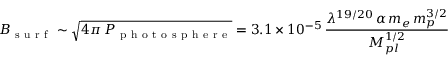Convert formula to latex. <formula><loc_0><loc_0><loc_500><loc_500>B _ { s u r f } \sim \sqrt { 4 \pi \, P _ { p h o t o s p h e r e } } = 3 . 1 \times 1 0 ^ { - 5 } \, \frac { \lambda ^ { 1 9 / 2 0 } \, \alpha \, m _ { e } \, m _ { p } ^ { 3 / 2 } } { M _ { p l } ^ { 1 / 2 } }</formula> 